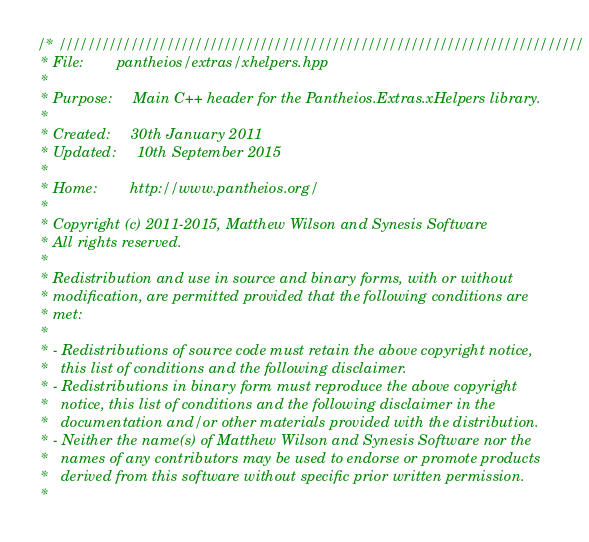<code> <loc_0><loc_0><loc_500><loc_500><_C++_>/* /////////////////////////////////////////////////////////////////////////
 * File:        pantheios/extras/xhelpers.hpp
 *
 * Purpose:     Main C++ header for the Pantheios.Extras.xHelpers library.
 *
 * Created:     30th January 2011
 * Updated:     10th September 2015
 *
 * Home:        http://www.pantheios.org/
 *
 * Copyright (c) 2011-2015, Matthew Wilson and Synesis Software
 * All rights reserved.
 *
 * Redistribution and use in source and binary forms, with or without
 * modification, are permitted provided that the following conditions are
 * met:
 *
 * - Redistributions of source code must retain the above copyright notice,
 *   this list of conditions and the following disclaimer.
 * - Redistributions in binary form must reproduce the above copyright
 *   notice, this list of conditions and the following disclaimer in the
 *   documentation and/or other materials provided with the distribution.
 * - Neither the name(s) of Matthew Wilson and Synesis Software nor the
 *   names of any contributors may be used to endorse or promote products
 *   derived from this software without specific prior written permission.
 *</code> 